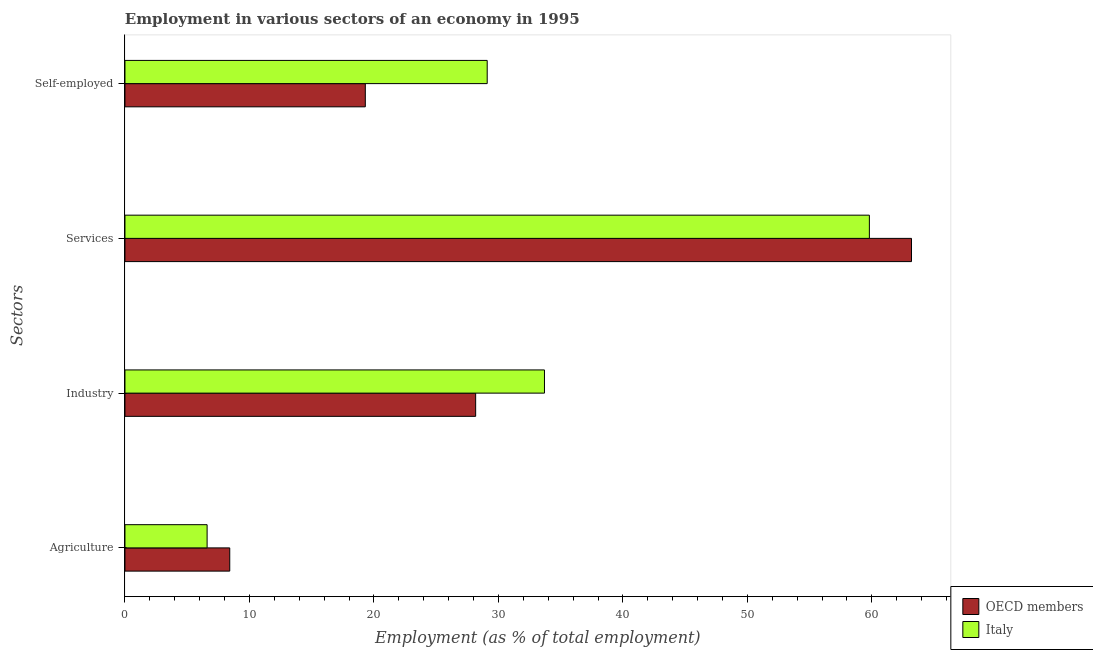How many groups of bars are there?
Give a very brief answer. 4. Are the number of bars on each tick of the Y-axis equal?
Give a very brief answer. Yes. What is the label of the 3rd group of bars from the top?
Offer a terse response. Industry. What is the percentage of workers in industry in Italy?
Keep it short and to the point. 33.7. Across all countries, what is the maximum percentage of self employed workers?
Your answer should be very brief. 29.1. Across all countries, what is the minimum percentage of workers in agriculture?
Offer a very short reply. 6.6. In which country was the percentage of workers in services minimum?
Offer a very short reply. Italy. What is the total percentage of workers in agriculture in the graph?
Provide a succinct answer. 15.02. What is the difference between the percentage of workers in industry in OECD members and that in Italy?
Provide a short and direct response. -5.53. What is the difference between the percentage of workers in industry in Italy and the percentage of workers in agriculture in OECD members?
Your answer should be very brief. 25.28. What is the average percentage of workers in industry per country?
Your response must be concise. 30.94. What is the difference between the percentage of workers in industry and percentage of workers in agriculture in Italy?
Give a very brief answer. 27.1. What is the ratio of the percentage of workers in services in OECD members to that in Italy?
Keep it short and to the point. 1.06. Is the difference between the percentage of self employed workers in Italy and OECD members greater than the difference between the percentage of workers in services in Italy and OECD members?
Make the answer very short. Yes. What is the difference between the highest and the second highest percentage of self employed workers?
Provide a succinct answer. 9.79. What is the difference between the highest and the lowest percentage of workers in agriculture?
Your response must be concise. 1.82. In how many countries, is the percentage of self employed workers greater than the average percentage of self employed workers taken over all countries?
Your answer should be compact. 1. What does the 2nd bar from the top in Agriculture represents?
Offer a terse response. OECD members. What does the 2nd bar from the bottom in Services represents?
Offer a very short reply. Italy. Is it the case that in every country, the sum of the percentage of workers in agriculture and percentage of workers in industry is greater than the percentage of workers in services?
Provide a short and direct response. No. Are all the bars in the graph horizontal?
Provide a short and direct response. Yes. What is the difference between two consecutive major ticks on the X-axis?
Make the answer very short. 10. Are the values on the major ticks of X-axis written in scientific E-notation?
Your answer should be compact. No. Does the graph contain grids?
Your response must be concise. No. Where does the legend appear in the graph?
Offer a terse response. Bottom right. How are the legend labels stacked?
Your response must be concise. Vertical. What is the title of the graph?
Ensure brevity in your answer.  Employment in various sectors of an economy in 1995. Does "Latin America(developing only)" appear as one of the legend labels in the graph?
Your answer should be very brief. No. What is the label or title of the X-axis?
Keep it short and to the point. Employment (as % of total employment). What is the label or title of the Y-axis?
Keep it short and to the point. Sectors. What is the Employment (as % of total employment) in OECD members in Agriculture?
Your answer should be compact. 8.42. What is the Employment (as % of total employment) of Italy in Agriculture?
Make the answer very short. 6.6. What is the Employment (as % of total employment) in OECD members in Industry?
Keep it short and to the point. 28.17. What is the Employment (as % of total employment) of Italy in Industry?
Your response must be concise. 33.7. What is the Employment (as % of total employment) of OECD members in Services?
Your answer should be very brief. 63.18. What is the Employment (as % of total employment) in Italy in Services?
Provide a succinct answer. 59.8. What is the Employment (as % of total employment) of OECD members in Self-employed?
Your answer should be compact. 19.31. What is the Employment (as % of total employment) of Italy in Self-employed?
Your answer should be very brief. 29.1. Across all Sectors, what is the maximum Employment (as % of total employment) of OECD members?
Ensure brevity in your answer.  63.18. Across all Sectors, what is the maximum Employment (as % of total employment) of Italy?
Provide a short and direct response. 59.8. Across all Sectors, what is the minimum Employment (as % of total employment) in OECD members?
Your answer should be compact. 8.42. Across all Sectors, what is the minimum Employment (as % of total employment) in Italy?
Offer a very short reply. 6.6. What is the total Employment (as % of total employment) of OECD members in the graph?
Give a very brief answer. 119.08. What is the total Employment (as % of total employment) in Italy in the graph?
Keep it short and to the point. 129.2. What is the difference between the Employment (as % of total employment) of OECD members in Agriculture and that in Industry?
Provide a succinct answer. -19.75. What is the difference between the Employment (as % of total employment) of Italy in Agriculture and that in Industry?
Make the answer very short. -27.1. What is the difference between the Employment (as % of total employment) in OECD members in Agriculture and that in Services?
Provide a succinct answer. -54.76. What is the difference between the Employment (as % of total employment) of Italy in Agriculture and that in Services?
Your answer should be very brief. -53.2. What is the difference between the Employment (as % of total employment) of OECD members in Agriculture and that in Self-employed?
Your answer should be very brief. -10.89. What is the difference between the Employment (as % of total employment) in Italy in Agriculture and that in Self-employed?
Give a very brief answer. -22.5. What is the difference between the Employment (as % of total employment) of OECD members in Industry and that in Services?
Provide a short and direct response. -35.01. What is the difference between the Employment (as % of total employment) in Italy in Industry and that in Services?
Your answer should be very brief. -26.1. What is the difference between the Employment (as % of total employment) in OECD members in Industry and that in Self-employed?
Your response must be concise. 8.86. What is the difference between the Employment (as % of total employment) of Italy in Industry and that in Self-employed?
Offer a very short reply. 4.6. What is the difference between the Employment (as % of total employment) of OECD members in Services and that in Self-employed?
Provide a succinct answer. 43.87. What is the difference between the Employment (as % of total employment) of Italy in Services and that in Self-employed?
Offer a terse response. 30.7. What is the difference between the Employment (as % of total employment) of OECD members in Agriculture and the Employment (as % of total employment) of Italy in Industry?
Your answer should be compact. -25.28. What is the difference between the Employment (as % of total employment) of OECD members in Agriculture and the Employment (as % of total employment) of Italy in Services?
Give a very brief answer. -51.38. What is the difference between the Employment (as % of total employment) of OECD members in Agriculture and the Employment (as % of total employment) of Italy in Self-employed?
Provide a short and direct response. -20.68. What is the difference between the Employment (as % of total employment) in OECD members in Industry and the Employment (as % of total employment) in Italy in Services?
Keep it short and to the point. -31.63. What is the difference between the Employment (as % of total employment) in OECD members in Industry and the Employment (as % of total employment) in Italy in Self-employed?
Provide a succinct answer. -0.93. What is the difference between the Employment (as % of total employment) in OECD members in Services and the Employment (as % of total employment) in Italy in Self-employed?
Your answer should be compact. 34.08. What is the average Employment (as % of total employment) in OECD members per Sectors?
Offer a very short reply. 29.77. What is the average Employment (as % of total employment) of Italy per Sectors?
Offer a terse response. 32.3. What is the difference between the Employment (as % of total employment) of OECD members and Employment (as % of total employment) of Italy in Agriculture?
Offer a very short reply. 1.82. What is the difference between the Employment (as % of total employment) in OECD members and Employment (as % of total employment) in Italy in Industry?
Provide a short and direct response. -5.53. What is the difference between the Employment (as % of total employment) in OECD members and Employment (as % of total employment) in Italy in Services?
Keep it short and to the point. 3.38. What is the difference between the Employment (as % of total employment) of OECD members and Employment (as % of total employment) of Italy in Self-employed?
Offer a very short reply. -9.79. What is the ratio of the Employment (as % of total employment) of OECD members in Agriculture to that in Industry?
Provide a short and direct response. 0.3. What is the ratio of the Employment (as % of total employment) in Italy in Agriculture to that in Industry?
Offer a terse response. 0.2. What is the ratio of the Employment (as % of total employment) of OECD members in Agriculture to that in Services?
Provide a succinct answer. 0.13. What is the ratio of the Employment (as % of total employment) of Italy in Agriculture to that in Services?
Your answer should be compact. 0.11. What is the ratio of the Employment (as % of total employment) of OECD members in Agriculture to that in Self-employed?
Your response must be concise. 0.44. What is the ratio of the Employment (as % of total employment) of Italy in Agriculture to that in Self-employed?
Your answer should be very brief. 0.23. What is the ratio of the Employment (as % of total employment) in OECD members in Industry to that in Services?
Offer a very short reply. 0.45. What is the ratio of the Employment (as % of total employment) in Italy in Industry to that in Services?
Give a very brief answer. 0.56. What is the ratio of the Employment (as % of total employment) of OECD members in Industry to that in Self-employed?
Give a very brief answer. 1.46. What is the ratio of the Employment (as % of total employment) of Italy in Industry to that in Self-employed?
Make the answer very short. 1.16. What is the ratio of the Employment (as % of total employment) of OECD members in Services to that in Self-employed?
Your response must be concise. 3.27. What is the ratio of the Employment (as % of total employment) in Italy in Services to that in Self-employed?
Make the answer very short. 2.06. What is the difference between the highest and the second highest Employment (as % of total employment) of OECD members?
Keep it short and to the point. 35.01. What is the difference between the highest and the second highest Employment (as % of total employment) in Italy?
Make the answer very short. 26.1. What is the difference between the highest and the lowest Employment (as % of total employment) in OECD members?
Your answer should be very brief. 54.76. What is the difference between the highest and the lowest Employment (as % of total employment) of Italy?
Offer a terse response. 53.2. 